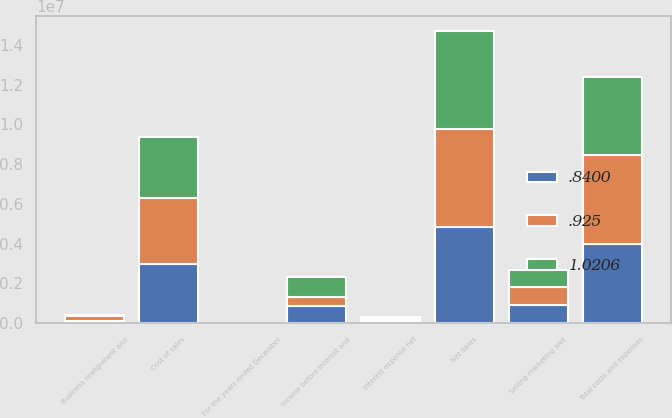Convert chart to OTSL. <chart><loc_0><loc_0><loc_500><loc_500><stacked_bar_chart><ecel><fcel>For the years ended December<fcel>Net Sales<fcel>Cost of sales<fcel>Selling marketing and<fcel>Business realignment and<fcel>Total costs and expenses<fcel>Income before Interest and<fcel>Interest expense net<nl><fcel>0.925<fcel>2007<fcel>4.94672e+06<fcel>3.31515e+06<fcel>895874<fcel>276868<fcel>4.48789e+06<fcel>458827<fcel>118585<nl><fcel>1.0206<fcel>2006<fcel>4.94423e+06<fcel>3.07672e+06<fcel>860378<fcel>14576<fcel>3.95167e+06<fcel>992558<fcel>116056<nl><fcel>0.84<fcel>2005<fcel>4.81983e+06<fcel>2.95668e+06<fcel>912986<fcel>96537<fcel>3.9662e+06<fcel>853622<fcel>87985<nl></chart> 